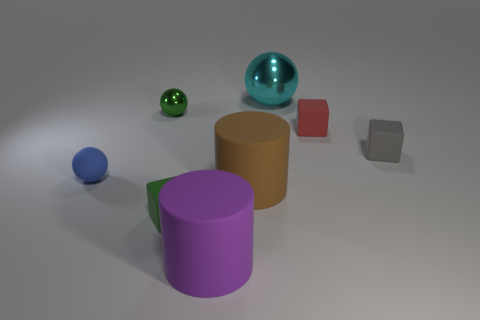Add 1 cyan things. How many objects exist? 9 Subtract all spheres. How many objects are left? 5 Add 1 purple matte objects. How many purple matte objects exist? 2 Subtract 0 green cylinders. How many objects are left? 8 Subtract all small yellow things. Subtract all small green cubes. How many objects are left? 7 Add 8 green things. How many green things are left? 10 